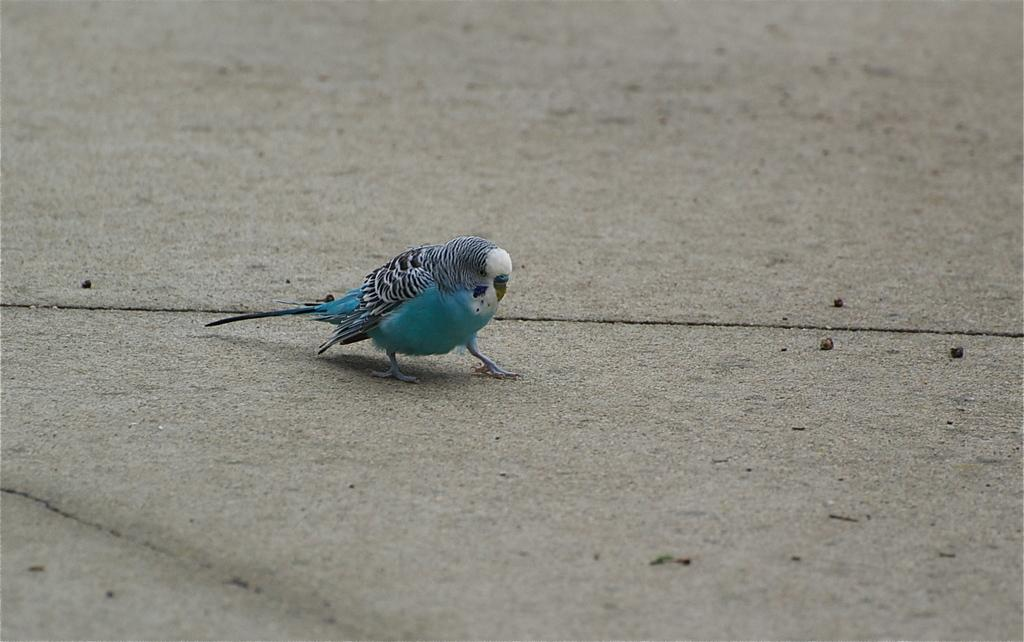What color is the parrot in the image? The parrot is blue in color. What type of bag is hanging from the parrot's beak in the image? There is no bag or beak present in the image, as it features a blue parrot. What color is the paint on the parrot's feathers in the image? There is no paint on the parrot's feathers in the image, as the parrot's color is naturally blue. 